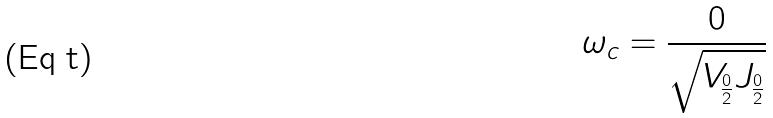Convert formula to latex. <formula><loc_0><loc_0><loc_500><loc_500>\omega _ { c } = \frac { 0 } { \sqrt { V _ { \frac { 0 } { 2 } } J _ { \frac { 0 } { 2 } } } }</formula> 